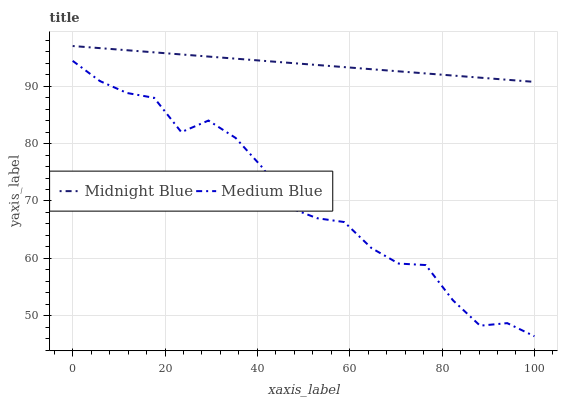Does Medium Blue have the minimum area under the curve?
Answer yes or no. Yes. Does Midnight Blue have the maximum area under the curve?
Answer yes or no. Yes. Does Midnight Blue have the minimum area under the curve?
Answer yes or no. No. Is Midnight Blue the smoothest?
Answer yes or no. Yes. Is Medium Blue the roughest?
Answer yes or no. Yes. Is Midnight Blue the roughest?
Answer yes or no. No. Does Medium Blue have the lowest value?
Answer yes or no. Yes. Does Midnight Blue have the lowest value?
Answer yes or no. No. Does Midnight Blue have the highest value?
Answer yes or no. Yes. Is Medium Blue less than Midnight Blue?
Answer yes or no. Yes. Is Midnight Blue greater than Medium Blue?
Answer yes or no. Yes. Does Medium Blue intersect Midnight Blue?
Answer yes or no. No. 